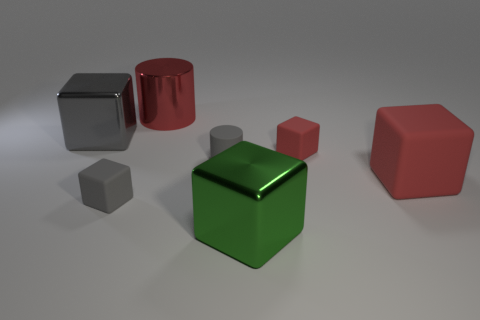Which of the objects in the image could represent the building blocks used in construction and architecture? In the world of architecture and construction, the cubes in this image can symbolize the modularity and uniformity of building blocks, like bricks or pre-fabricated modules. They demonstrate how repeating identical shapes can be used to create larger structures with stability and symmetry.  How can the lighting in this scene help understand object material? The lighting in this scene is key to revealing the material properties of the objects: it highlights the sheen on the metallic surfaces and the more diffuse reflection on the matte objects. The way light reflects and casts shadows can tell us a lot about the texture and makeup of each item. 